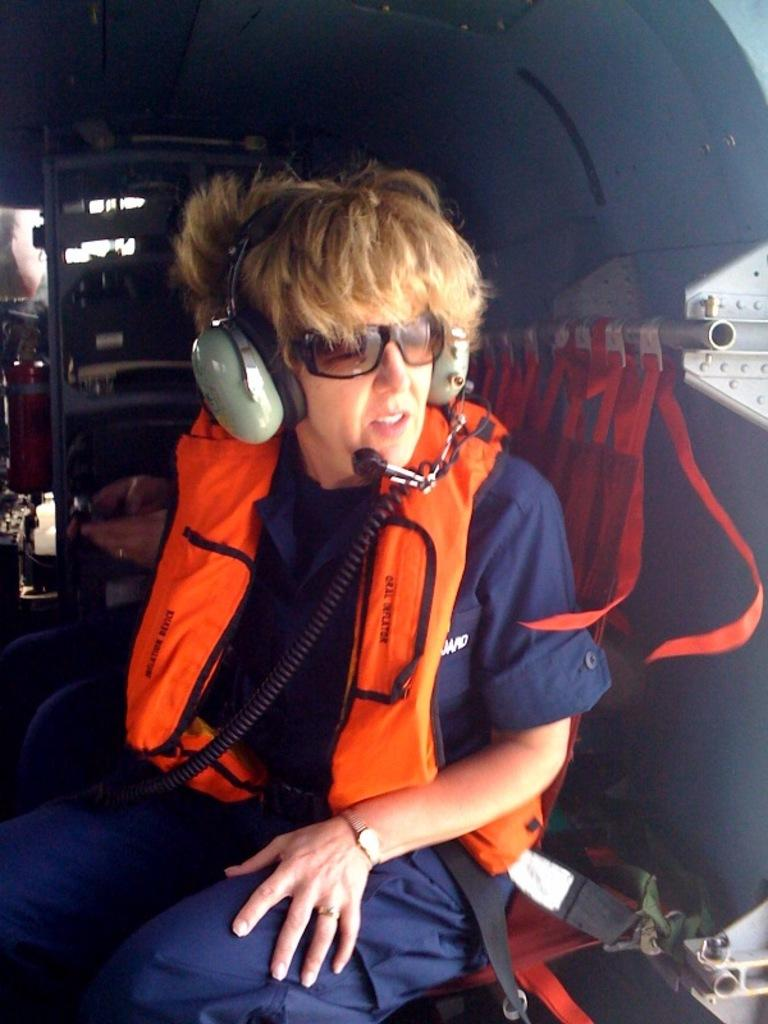What is the setting of the image? The image is inside a vehicle. What safety equipment is the person wearing in the image? The person is wearing a life jacket. What type of headgear is the person wearing in the image? The person is wearing a headset. What type of eyewear is the person wearing in the image? The person is wearing goggles. Can you describe any objects visible in the background of the image? Unfortunately, the provided facts do not mention any specific objects in the background. What type of sweater is the person wearing in the image? There is no sweater visible in the image; the person is wearing a life jacket, headset, and goggles. 